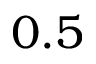Convert formula to latex. <formula><loc_0><loc_0><loc_500><loc_500>0 . 5</formula> 